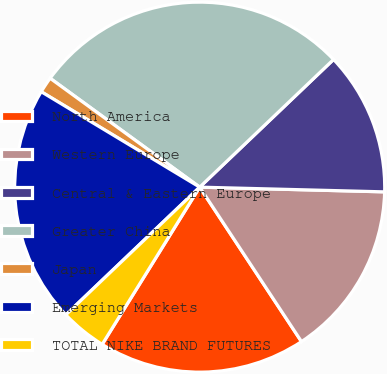Convert chart to OTSL. <chart><loc_0><loc_0><loc_500><loc_500><pie_chart><fcel>North America<fcel>Western Europe<fcel>Central & Eastern Europe<fcel>Greater China<fcel>Japan<fcel>Emerging Markets<fcel>TOTAL NIKE BRAND FUTURES<nl><fcel>18.11%<fcel>15.32%<fcel>12.53%<fcel>27.86%<fcel>1.39%<fcel>20.75%<fcel>4.04%<nl></chart> 